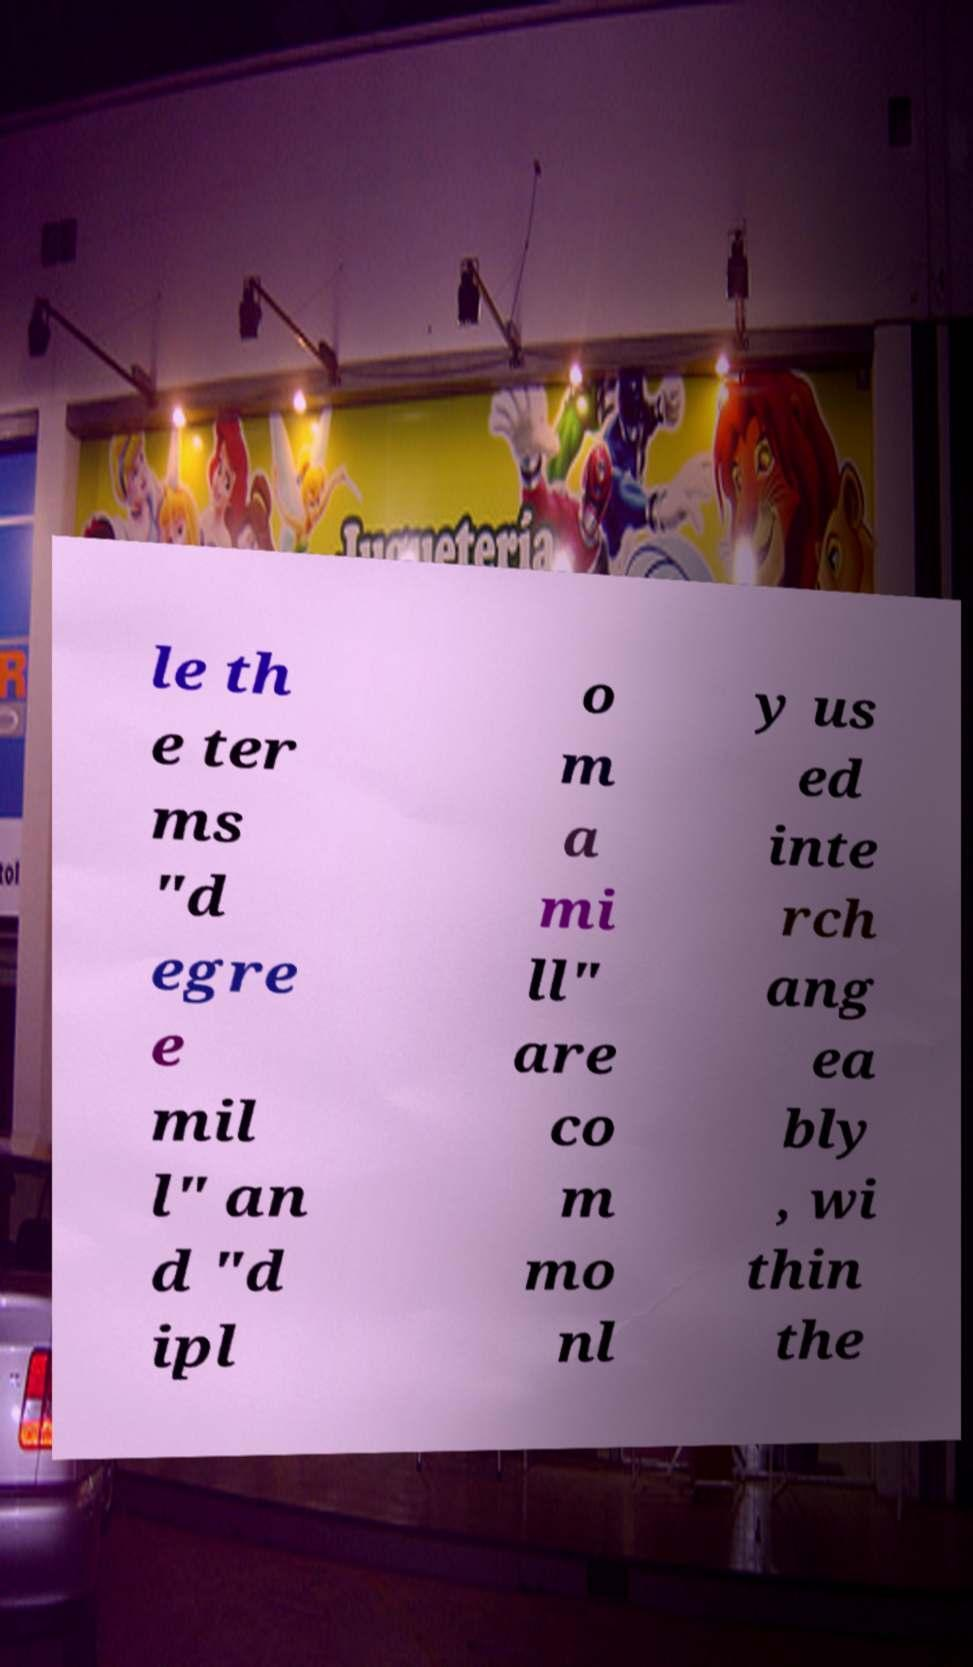Could you extract and type out the text from this image? le th e ter ms "d egre e mil l" an d "d ipl o m a mi ll" are co m mo nl y us ed inte rch ang ea bly , wi thin the 